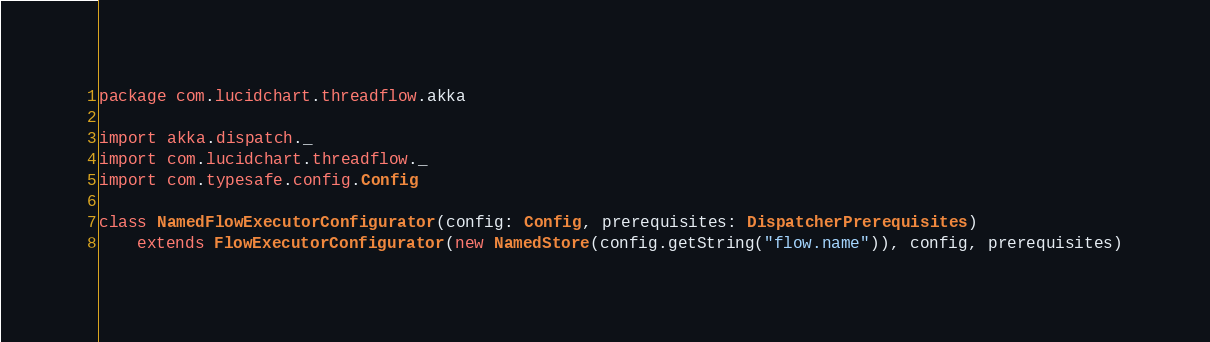<code> <loc_0><loc_0><loc_500><loc_500><_Scala_>package com.lucidchart.threadflow.akka

import akka.dispatch._
import com.lucidchart.threadflow._
import com.typesafe.config.Config

class NamedFlowExecutorConfigurator(config: Config, prerequisites: DispatcherPrerequisites)
    extends FlowExecutorConfigurator(new NamedStore(config.getString("flow.name")), config, prerequisites)
</code> 